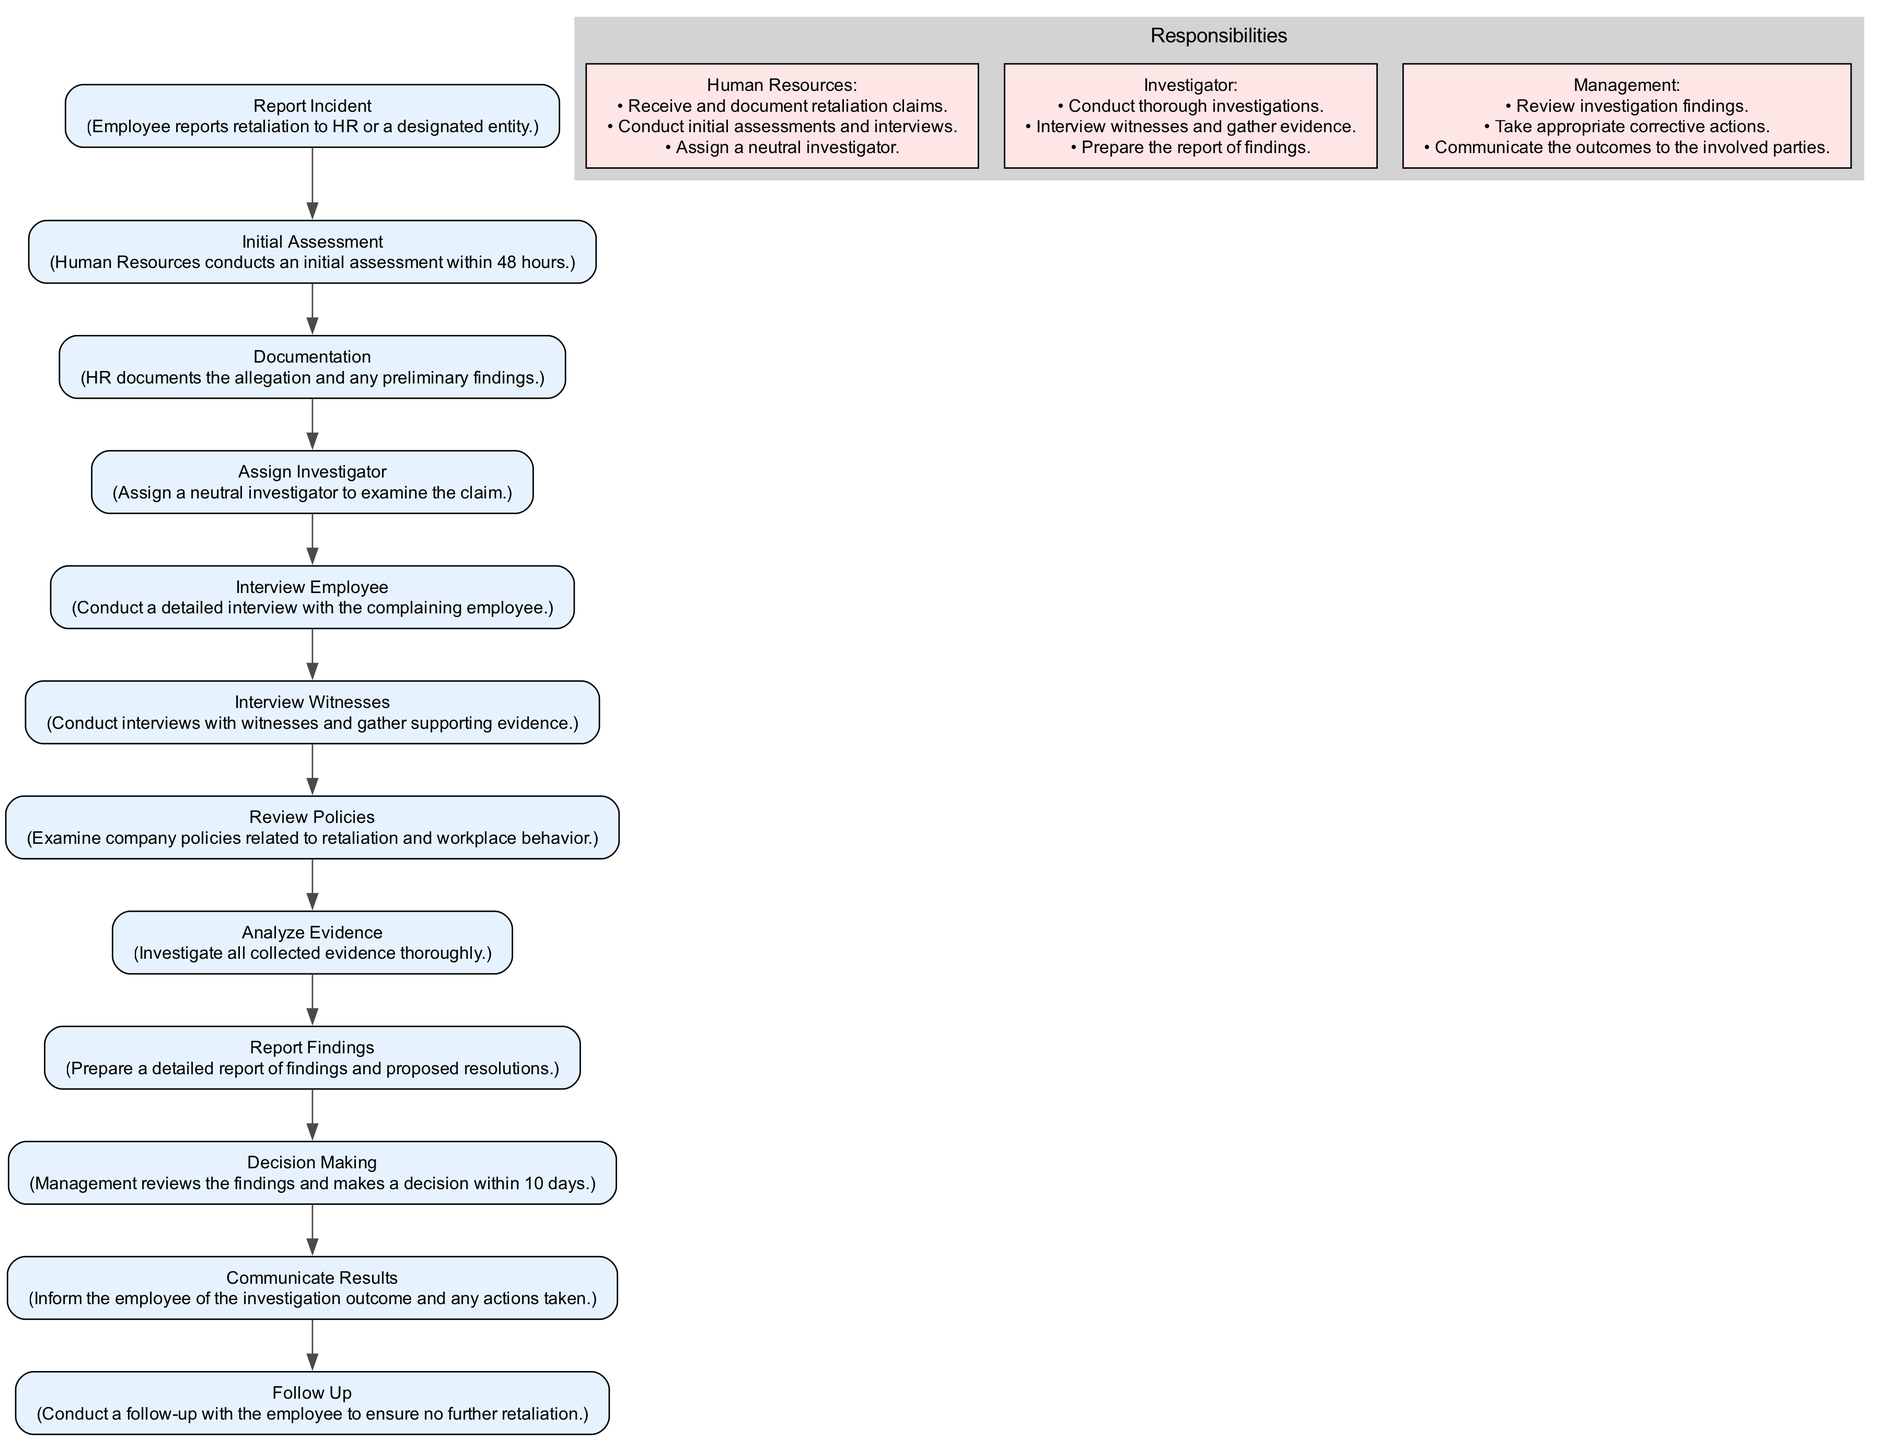What is the first step in addressing retaliation claims? The first step listed in the diagram is "Report Incident," where the employee reports retaliation to HR or a designated entity.
Answer: Report Incident How many total steps are involved in the process? By counting the steps listed in the diagram, there are 12 total steps related to addressing retaliation claims.
Answer: 12 What is the role of Human Resources in the process? Human Resources is responsible for receiving and documenting retaliation claims, conducting initial assessments and interviews, and assigning a neutral investigator.
Answer: Receive and document retaliation claims Which step follows the "Interview Employee" step? According to the flow in the diagram, the step that follows "Interview Employee" is "Interview Witnesses."
Answer: Interview Witnesses What is the time frame for management to make a decision? The diagram specifies that management reviews findings and makes a decision within 10 days after the investigation.
Answer: 10 days What document is prepared after analyzing evidence? After analyzing evidence, the next document prepared is the "Report Findings," which details the findings and proposed resolutions.
Answer: Report Findings Which node describes the role of the investigator? The responsibilities of the Investigator are described in the subgraph in the diagram where it states they must conduct thorough investigations and prepare the report of findings.
Answer: Conduct thorough investigations What is the last step in the pathway? The last step in the diagram is "Follow Up," ensuring no further retaliation against the employee occurs after the investigation.
Answer: Follow Up Which step involves examining company policies? The step that involves examining company policies is "Review Policies," which is aimed at understanding the context of the retaliation claim.
Answer: Review Policies What happens during the "Communicate Results" step? During the "Communicate Results" step, the employee is informed of the investigation outcome and any actions taken by the management.
Answer: Inform the employee of the investigation outcome 